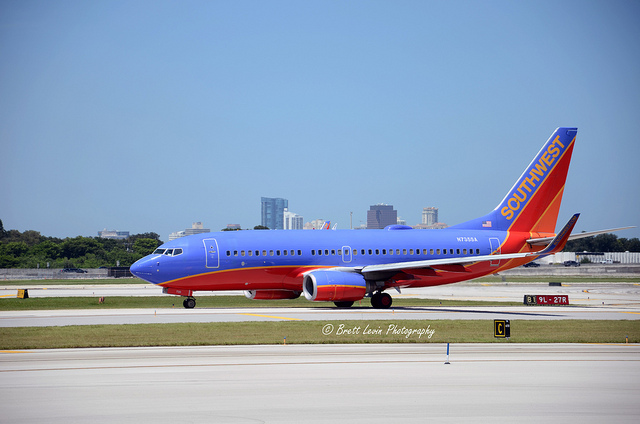Identify and read out the text in this image. SOUTHWEST 9L 27R photography brett C 